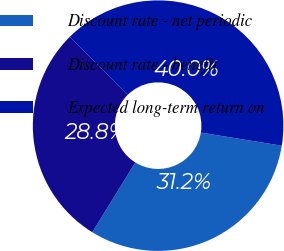Convert chart to OTSL. <chart><loc_0><loc_0><loc_500><loc_500><pie_chart><fcel>Discount rate - net periodic<fcel>Discount rate - benefit<fcel>Expected long-term return on<nl><fcel>31.25%<fcel>28.75%<fcel>40.0%<nl></chart> 